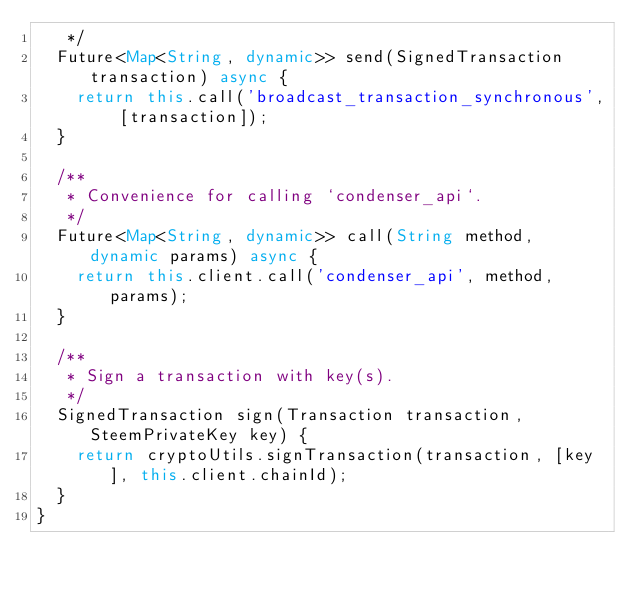Convert code to text. <code><loc_0><loc_0><loc_500><loc_500><_Dart_>   */
  Future<Map<String, dynamic>> send(SignedTransaction transaction) async {
    return this.call('broadcast_transaction_synchronous', [transaction]);
  }

  /**
   * Convenience for calling `condenser_api`.
   */
  Future<Map<String, dynamic>> call(String method, dynamic params) async {
    return this.client.call('condenser_api', method, params);
  }

  /**
   * Sign a transaction with key(s).
   */
  SignedTransaction sign(Transaction transaction, SteemPrivateKey key) {
    return cryptoUtils.signTransaction(transaction, [key], this.client.chainId);
  }
}
</code> 